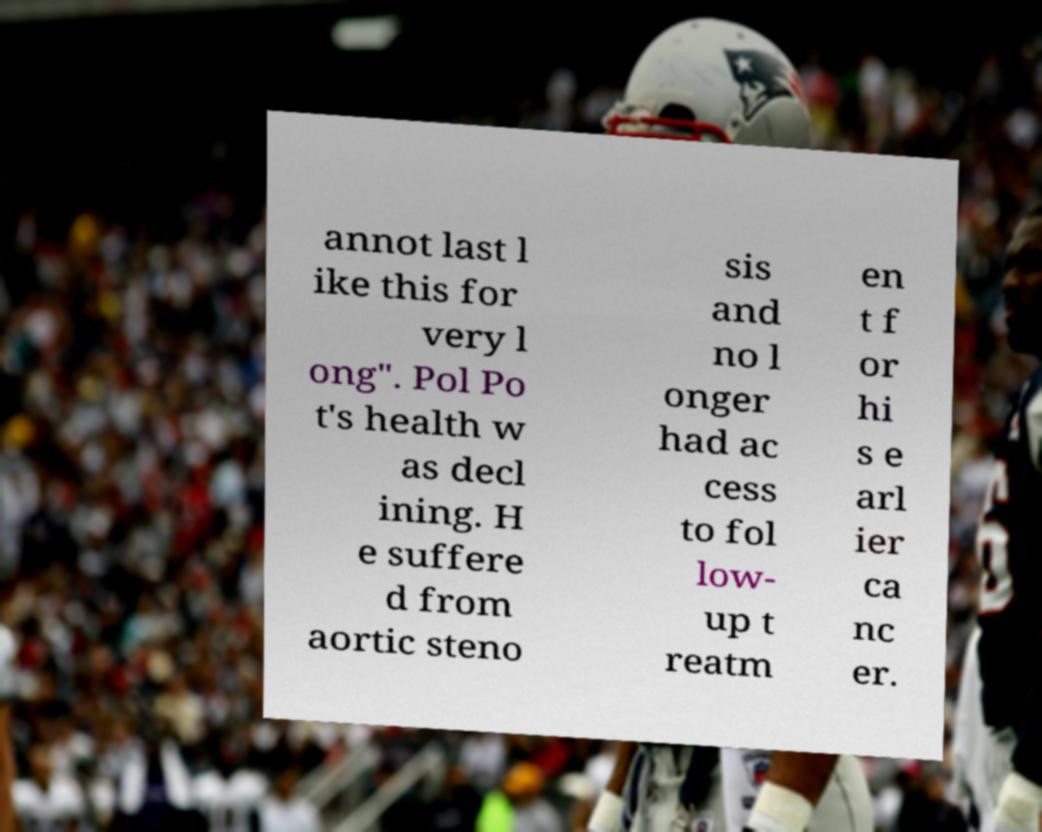Please identify and transcribe the text found in this image. annot last l ike this for very l ong". Pol Po t's health w as decl ining. H e suffere d from aortic steno sis and no l onger had ac cess to fol low- up t reatm en t f or hi s e arl ier ca nc er. 